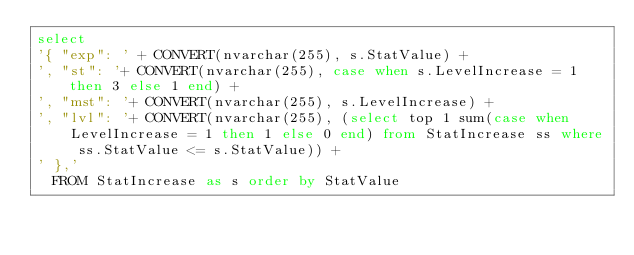<code> <loc_0><loc_0><loc_500><loc_500><_SQL_>select 
'{ "exp": ' + CONVERT(nvarchar(255), s.StatValue) + 
', "st": '+ CONVERT(nvarchar(255), case when s.LevelIncrease = 1 then 3 else 1 end) +
', "mst": '+ CONVERT(nvarchar(255), s.LevelIncrease) +
', "lvl": '+ CONVERT(nvarchar(255), (select top 1 sum(case when LevelIncrease = 1 then 1 else 0 end) from StatIncrease ss where ss.StatValue <= s.StatValue)) + 
' },'
  FROM StatIncrease as s order by StatValue</code> 